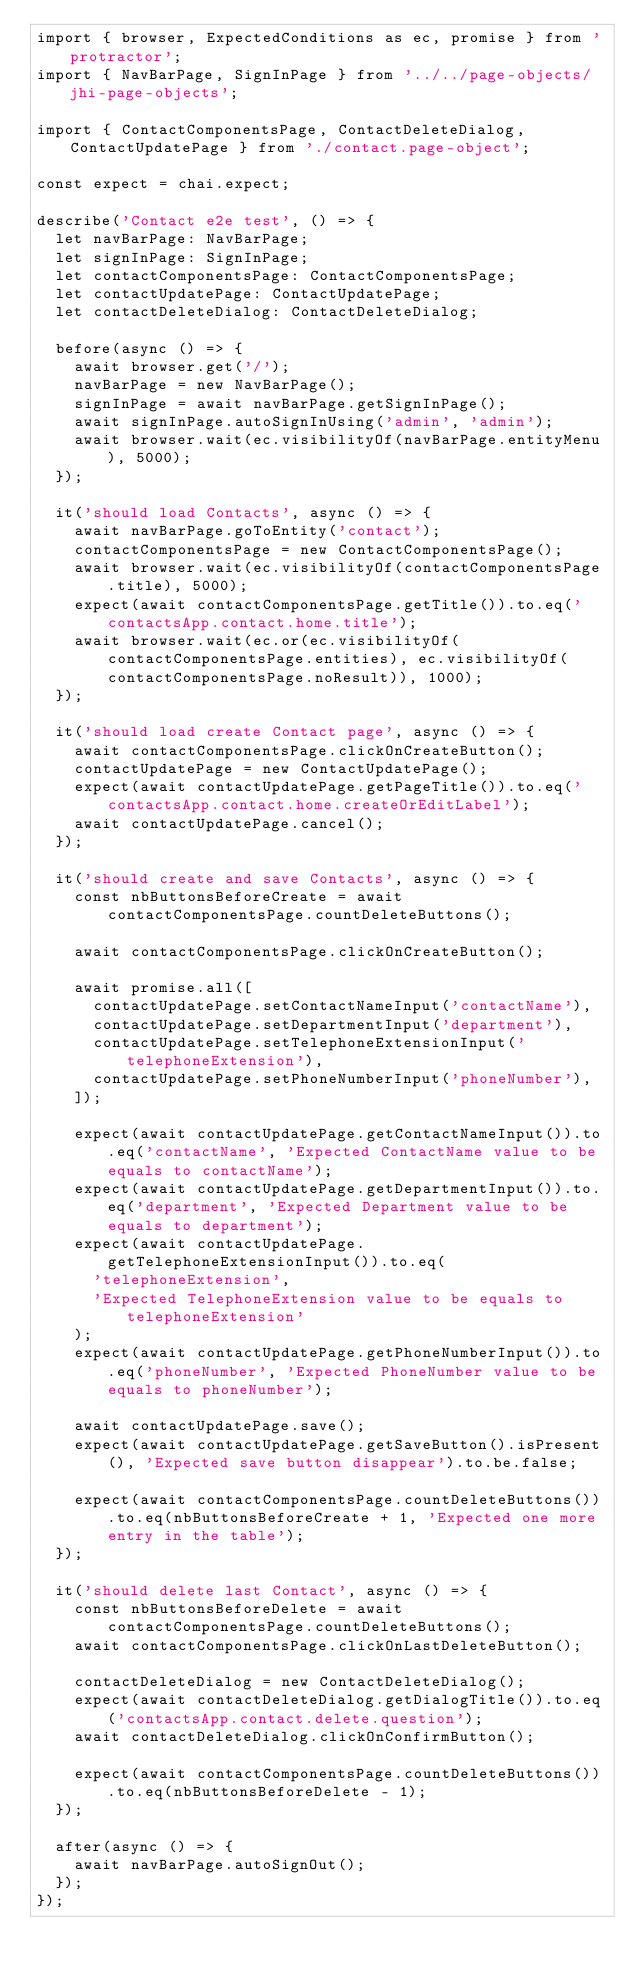<code> <loc_0><loc_0><loc_500><loc_500><_TypeScript_>import { browser, ExpectedConditions as ec, promise } from 'protractor';
import { NavBarPage, SignInPage } from '../../page-objects/jhi-page-objects';

import { ContactComponentsPage, ContactDeleteDialog, ContactUpdatePage } from './contact.page-object';

const expect = chai.expect;

describe('Contact e2e test', () => {
  let navBarPage: NavBarPage;
  let signInPage: SignInPage;
  let contactComponentsPage: ContactComponentsPage;
  let contactUpdatePage: ContactUpdatePage;
  let contactDeleteDialog: ContactDeleteDialog;

  before(async () => {
    await browser.get('/');
    navBarPage = new NavBarPage();
    signInPage = await navBarPage.getSignInPage();
    await signInPage.autoSignInUsing('admin', 'admin');
    await browser.wait(ec.visibilityOf(navBarPage.entityMenu), 5000);
  });

  it('should load Contacts', async () => {
    await navBarPage.goToEntity('contact');
    contactComponentsPage = new ContactComponentsPage();
    await browser.wait(ec.visibilityOf(contactComponentsPage.title), 5000);
    expect(await contactComponentsPage.getTitle()).to.eq('contactsApp.contact.home.title');
    await browser.wait(ec.or(ec.visibilityOf(contactComponentsPage.entities), ec.visibilityOf(contactComponentsPage.noResult)), 1000);
  });

  it('should load create Contact page', async () => {
    await contactComponentsPage.clickOnCreateButton();
    contactUpdatePage = new ContactUpdatePage();
    expect(await contactUpdatePage.getPageTitle()).to.eq('contactsApp.contact.home.createOrEditLabel');
    await contactUpdatePage.cancel();
  });

  it('should create and save Contacts', async () => {
    const nbButtonsBeforeCreate = await contactComponentsPage.countDeleteButtons();

    await contactComponentsPage.clickOnCreateButton();

    await promise.all([
      contactUpdatePage.setContactNameInput('contactName'),
      contactUpdatePage.setDepartmentInput('department'),
      contactUpdatePage.setTelephoneExtensionInput('telephoneExtension'),
      contactUpdatePage.setPhoneNumberInput('phoneNumber'),
    ]);

    expect(await contactUpdatePage.getContactNameInput()).to.eq('contactName', 'Expected ContactName value to be equals to contactName');
    expect(await contactUpdatePage.getDepartmentInput()).to.eq('department', 'Expected Department value to be equals to department');
    expect(await contactUpdatePage.getTelephoneExtensionInput()).to.eq(
      'telephoneExtension',
      'Expected TelephoneExtension value to be equals to telephoneExtension'
    );
    expect(await contactUpdatePage.getPhoneNumberInput()).to.eq('phoneNumber', 'Expected PhoneNumber value to be equals to phoneNumber');

    await contactUpdatePage.save();
    expect(await contactUpdatePage.getSaveButton().isPresent(), 'Expected save button disappear').to.be.false;

    expect(await contactComponentsPage.countDeleteButtons()).to.eq(nbButtonsBeforeCreate + 1, 'Expected one more entry in the table');
  });

  it('should delete last Contact', async () => {
    const nbButtonsBeforeDelete = await contactComponentsPage.countDeleteButtons();
    await contactComponentsPage.clickOnLastDeleteButton();

    contactDeleteDialog = new ContactDeleteDialog();
    expect(await contactDeleteDialog.getDialogTitle()).to.eq('contactsApp.contact.delete.question');
    await contactDeleteDialog.clickOnConfirmButton();

    expect(await contactComponentsPage.countDeleteButtons()).to.eq(nbButtonsBeforeDelete - 1);
  });

  after(async () => {
    await navBarPage.autoSignOut();
  });
});
</code> 